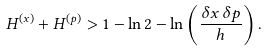Convert formula to latex. <formula><loc_0><loc_0><loc_500><loc_500>H ^ { ( x ) } + H ^ { ( p ) } > 1 - \ln 2 - \ln \left ( \frac { \delta x \, \delta p } { h } \right ) .</formula> 